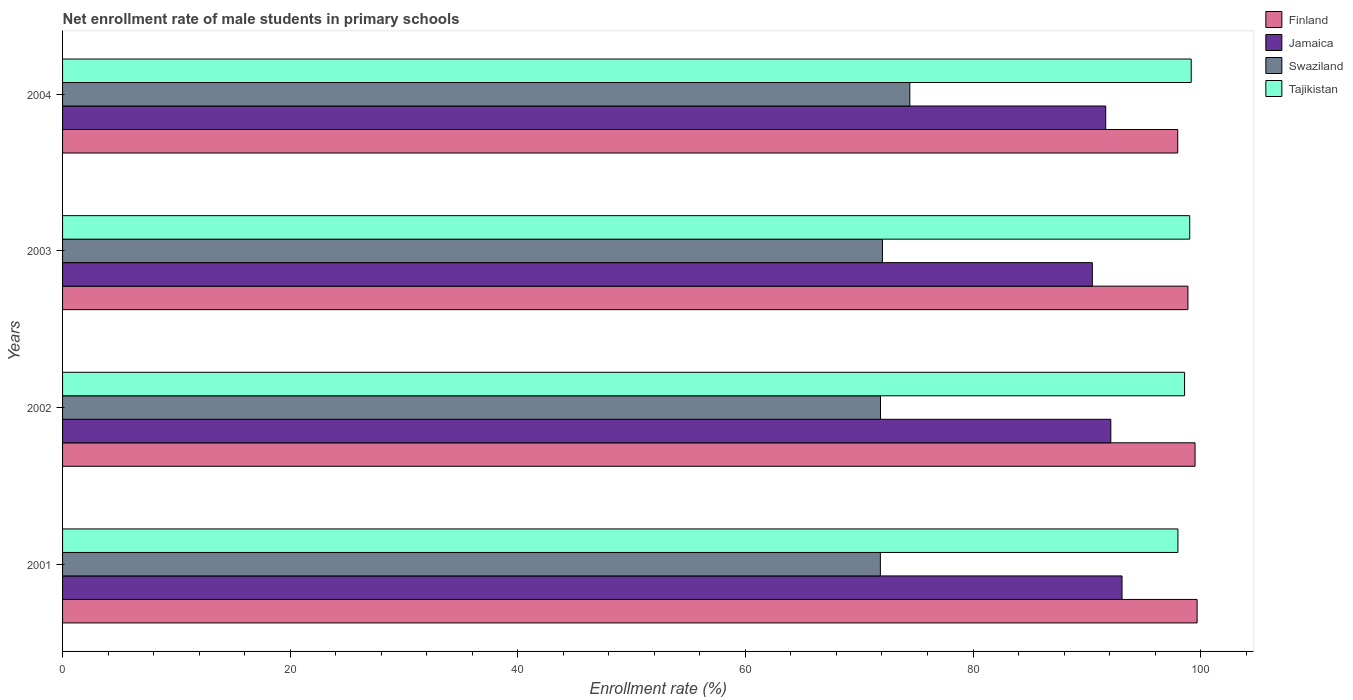How many groups of bars are there?
Keep it short and to the point. 4. How many bars are there on the 4th tick from the top?
Keep it short and to the point. 4. What is the label of the 3rd group of bars from the top?
Your response must be concise. 2002. What is the net enrollment rate of male students in primary schools in Finland in 2002?
Your answer should be very brief. 99.51. Across all years, what is the maximum net enrollment rate of male students in primary schools in Tajikistan?
Your response must be concise. 99.17. Across all years, what is the minimum net enrollment rate of male students in primary schools in Finland?
Provide a short and direct response. 97.99. In which year was the net enrollment rate of male students in primary schools in Finland minimum?
Provide a short and direct response. 2004. What is the total net enrollment rate of male students in primary schools in Jamaica in the graph?
Provide a succinct answer. 367.34. What is the difference between the net enrollment rate of male students in primary schools in Finland in 2002 and that in 2004?
Offer a very short reply. 1.52. What is the difference between the net enrollment rate of male students in primary schools in Swaziland in 2004 and the net enrollment rate of male students in primary schools in Jamaica in 2003?
Make the answer very short. -16.04. What is the average net enrollment rate of male students in primary schools in Tajikistan per year?
Your answer should be very brief. 98.7. In the year 2001, what is the difference between the net enrollment rate of male students in primary schools in Finland and net enrollment rate of male students in primary schools in Swaziland?
Provide a short and direct response. 27.83. What is the ratio of the net enrollment rate of male students in primary schools in Finland in 2001 to that in 2004?
Your answer should be very brief. 1.02. Is the difference between the net enrollment rate of male students in primary schools in Finland in 2002 and 2003 greater than the difference between the net enrollment rate of male students in primary schools in Swaziland in 2002 and 2003?
Ensure brevity in your answer.  Yes. What is the difference between the highest and the second highest net enrollment rate of male students in primary schools in Swaziland?
Your answer should be compact. 2.41. What is the difference between the highest and the lowest net enrollment rate of male students in primary schools in Finland?
Offer a very short reply. 1.7. Is the sum of the net enrollment rate of male students in primary schools in Jamaica in 2001 and 2002 greater than the maximum net enrollment rate of male students in primary schools in Tajikistan across all years?
Your response must be concise. Yes. What does the 2nd bar from the top in 2002 represents?
Your answer should be compact. Swaziland. What does the 4th bar from the bottom in 2004 represents?
Your response must be concise. Tajikistan. How many bars are there?
Offer a terse response. 16. How many years are there in the graph?
Keep it short and to the point. 4. What is the difference between two consecutive major ticks on the X-axis?
Keep it short and to the point. 20. Are the values on the major ticks of X-axis written in scientific E-notation?
Offer a terse response. No. Does the graph contain any zero values?
Give a very brief answer. No. How many legend labels are there?
Keep it short and to the point. 4. What is the title of the graph?
Your response must be concise. Net enrollment rate of male students in primary schools. What is the label or title of the X-axis?
Your answer should be compact. Enrollment rate (%). What is the label or title of the Y-axis?
Make the answer very short. Years. What is the Enrollment rate (%) in Finland in 2001?
Give a very brief answer. 99.69. What is the Enrollment rate (%) in Jamaica in 2001?
Offer a terse response. 93.09. What is the Enrollment rate (%) of Swaziland in 2001?
Offer a terse response. 71.86. What is the Enrollment rate (%) of Tajikistan in 2001?
Your answer should be compact. 98.01. What is the Enrollment rate (%) in Finland in 2002?
Provide a short and direct response. 99.51. What is the Enrollment rate (%) of Jamaica in 2002?
Ensure brevity in your answer.  92.11. What is the Enrollment rate (%) of Swaziland in 2002?
Offer a terse response. 71.87. What is the Enrollment rate (%) in Tajikistan in 2002?
Your answer should be compact. 98.59. What is the Enrollment rate (%) of Finland in 2003?
Your answer should be very brief. 98.88. What is the Enrollment rate (%) of Jamaica in 2003?
Offer a very short reply. 90.48. What is the Enrollment rate (%) of Swaziland in 2003?
Provide a succinct answer. 72.04. What is the Enrollment rate (%) in Tajikistan in 2003?
Provide a succinct answer. 99.04. What is the Enrollment rate (%) of Finland in 2004?
Provide a short and direct response. 97.99. What is the Enrollment rate (%) of Jamaica in 2004?
Give a very brief answer. 91.66. What is the Enrollment rate (%) of Swaziland in 2004?
Your answer should be compact. 74.45. What is the Enrollment rate (%) of Tajikistan in 2004?
Provide a short and direct response. 99.17. Across all years, what is the maximum Enrollment rate (%) in Finland?
Your answer should be compact. 99.69. Across all years, what is the maximum Enrollment rate (%) in Jamaica?
Your response must be concise. 93.09. Across all years, what is the maximum Enrollment rate (%) of Swaziland?
Offer a terse response. 74.45. Across all years, what is the maximum Enrollment rate (%) of Tajikistan?
Provide a succinct answer. 99.17. Across all years, what is the minimum Enrollment rate (%) in Finland?
Give a very brief answer. 97.99. Across all years, what is the minimum Enrollment rate (%) of Jamaica?
Give a very brief answer. 90.48. Across all years, what is the minimum Enrollment rate (%) of Swaziland?
Provide a succinct answer. 71.86. Across all years, what is the minimum Enrollment rate (%) of Tajikistan?
Make the answer very short. 98.01. What is the total Enrollment rate (%) of Finland in the graph?
Provide a succinct answer. 396.07. What is the total Enrollment rate (%) in Jamaica in the graph?
Give a very brief answer. 367.34. What is the total Enrollment rate (%) of Swaziland in the graph?
Your answer should be very brief. 290.21. What is the total Enrollment rate (%) in Tajikistan in the graph?
Provide a short and direct response. 394.81. What is the difference between the Enrollment rate (%) in Finland in 2001 and that in 2002?
Provide a short and direct response. 0.18. What is the difference between the Enrollment rate (%) in Jamaica in 2001 and that in 2002?
Your answer should be compact. 0.99. What is the difference between the Enrollment rate (%) in Swaziland in 2001 and that in 2002?
Your response must be concise. -0.01. What is the difference between the Enrollment rate (%) in Tajikistan in 2001 and that in 2002?
Ensure brevity in your answer.  -0.58. What is the difference between the Enrollment rate (%) in Finland in 2001 and that in 2003?
Make the answer very short. 0.81. What is the difference between the Enrollment rate (%) of Jamaica in 2001 and that in 2003?
Offer a very short reply. 2.61. What is the difference between the Enrollment rate (%) in Swaziland in 2001 and that in 2003?
Offer a terse response. -0.18. What is the difference between the Enrollment rate (%) of Tajikistan in 2001 and that in 2003?
Make the answer very short. -1.04. What is the difference between the Enrollment rate (%) in Finland in 2001 and that in 2004?
Provide a short and direct response. 1.7. What is the difference between the Enrollment rate (%) of Jamaica in 2001 and that in 2004?
Offer a very short reply. 1.43. What is the difference between the Enrollment rate (%) in Swaziland in 2001 and that in 2004?
Your answer should be very brief. -2.59. What is the difference between the Enrollment rate (%) in Tajikistan in 2001 and that in 2004?
Offer a very short reply. -1.17. What is the difference between the Enrollment rate (%) in Finland in 2002 and that in 2003?
Provide a short and direct response. 0.63. What is the difference between the Enrollment rate (%) in Jamaica in 2002 and that in 2003?
Provide a short and direct response. 1.62. What is the difference between the Enrollment rate (%) in Swaziland in 2002 and that in 2003?
Provide a short and direct response. -0.17. What is the difference between the Enrollment rate (%) of Tajikistan in 2002 and that in 2003?
Provide a short and direct response. -0.46. What is the difference between the Enrollment rate (%) of Finland in 2002 and that in 2004?
Provide a short and direct response. 1.52. What is the difference between the Enrollment rate (%) in Jamaica in 2002 and that in 2004?
Provide a succinct answer. 0.45. What is the difference between the Enrollment rate (%) of Swaziland in 2002 and that in 2004?
Keep it short and to the point. -2.57. What is the difference between the Enrollment rate (%) in Tajikistan in 2002 and that in 2004?
Make the answer very short. -0.58. What is the difference between the Enrollment rate (%) in Finland in 2003 and that in 2004?
Provide a short and direct response. 0.9. What is the difference between the Enrollment rate (%) of Jamaica in 2003 and that in 2004?
Make the answer very short. -1.17. What is the difference between the Enrollment rate (%) of Swaziland in 2003 and that in 2004?
Offer a very short reply. -2.41. What is the difference between the Enrollment rate (%) in Tajikistan in 2003 and that in 2004?
Ensure brevity in your answer.  -0.13. What is the difference between the Enrollment rate (%) of Finland in 2001 and the Enrollment rate (%) of Jamaica in 2002?
Offer a very short reply. 7.58. What is the difference between the Enrollment rate (%) of Finland in 2001 and the Enrollment rate (%) of Swaziland in 2002?
Provide a short and direct response. 27.82. What is the difference between the Enrollment rate (%) of Finland in 2001 and the Enrollment rate (%) of Tajikistan in 2002?
Provide a short and direct response. 1.1. What is the difference between the Enrollment rate (%) of Jamaica in 2001 and the Enrollment rate (%) of Swaziland in 2002?
Your response must be concise. 21.22. What is the difference between the Enrollment rate (%) of Jamaica in 2001 and the Enrollment rate (%) of Tajikistan in 2002?
Make the answer very short. -5.49. What is the difference between the Enrollment rate (%) of Swaziland in 2001 and the Enrollment rate (%) of Tajikistan in 2002?
Give a very brief answer. -26.73. What is the difference between the Enrollment rate (%) in Finland in 2001 and the Enrollment rate (%) in Jamaica in 2003?
Provide a short and direct response. 9.21. What is the difference between the Enrollment rate (%) of Finland in 2001 and the Enrollment rate (%) of Swaziland in 2003?
Offer a terse response. 27.65. What is the difference between the Enrollment rate (%) of Finland in 2001 and the Enrollment rate (%) of Tajikistan in 2003?
Your answer should be compact. 0.65. What is the difference between the Enrollment rate (%) of Jamaica in 2001 and the Enrollment rate (%) of Swaziland in 2003?
Make the answer very short. 21.05. What is the difference between the Enrollment rate (%) in Jamaica in 2001 and the Enrollment rate (%) in Tajikistan in 2003?
Make the answer very short. -5.95. What is the difference between the Enrollment rate (%) of Swaziland in 2001 and the Enrollment rate (%) of Tajikistan in 2003?
Offer a very short reply. -27.19. What is the difference between the Enrollment rate (%) in Finland in 2001 and the Enrollment rate (%) in Jamaica in 2004?
Provide a succinct answer. 8.03. What is the difference between the Enrollment rate (%) in Finland in 2001 and the Enrollment rate (%) in Swaziland in 2004?
Keep it short and to the point. 25.24. What is the difference between the Enrollment rate (%) of Finland in 2001 and the Enrollment rate (%) of Tajikistan in 2004?
Your response must be concise. 0.52. What is the difference between the Enrollment rate (%) in Jamaica in 2001 and the Enrollment rate (%) in Swaziland in 2004?
Offer a very short reply. 18.65. What is the difference between the Enrollment rate (%) of Jamaica in 2001 and the Enrollment rate (%) of Tajikistan in 2004?
Offer a very short reply. -6.08. What is the difference between the Enrollment rate (%) in Swaziland in 2001 and the Enrollment rate (%) in Tajikistan in 2004?
Provide a short and direct response. -27.31. What is the difference between the Enrollment rate (%) in Finland in 2002 and the Enrollment rate (%) in Jamaica in 2003?
Your response must be concise. 9.03. What is the difference between the Enrollment rate (%) in Finland in 2002 and the Enrollment rate (%) in Swaziland in 2003?
Provide a succinct answer. 27.47. What is the difference between the Enrollment rate (%) in Finland in 2002 and the Enrollment rate (%) in Tajikistan in 2003?
Ensure brevity in your answer.  0.47. What is the difference between the Enrollment rate (%) in Jamaica in 2002 and the Enrollment rate (%) in Swaziland in 2003?
Your answer should be very brief. 20.07. What is the difference between the Enrollment rate (%) in Jamaica in 2002 and the Enrollment rate (%) in Tajikistan in 2003?
Your answer should be very brief. -6.94. What is the difference between the Enrollment rate (%) in Swaziland in 2002 and the Enrollment rate (%) in Tajikistan in 2003?
Your response must be concise. -27.17. What is the difference between the Enrollment rate (%) in Finland in 2002 and the Enrollment rate (%) in Jamaica in 2004?
Your answer should be very brief. 7.85. What is the difference between the Enrollment rate (%) in Finland in 2002 and the Enrollment rate (%) in Swaziland in 2004?
Give a very brief answer. 25.06. What is the difference between the Enrollment rate (%) of Finland in 2002 and the Enrollment rate (%) of Tajikistan in 2004?
Provide a short and direct response. 0.34. What is the difference between the Enrollment rate (%) in Jamaica in 2002 and the Enrollment rate (%) in Swaziland in 2004?
Provide a short and direct response. 17.66. What is the difference between the Enrollment rate (%) of Jamaica in 2002 and the Enrollment rate (%) of Tajikistan in 2004?
Your response must be concise. -7.06. What is the difference between the Enrollment rate (%) of Swaziland in 2002 and the Enrollment rate (%) of Tajikistan in 2004?
Ensure brevity in your answer.  -27.3. What is the difference between the Enrollment rate (%) of Finland in 2003 and the Enrollment rate (%) of Jamaica in 2004?
Make the answer very short. 7.23. What is the difference between the Enrollment rate (%) in Finland in 2003 and the Enrollment rate (%) in Swaziland in 2004?
Provide a succinct answer. 24.44. What is the difference between the Enrollment rate (%) of Finland in 2003 and the Enrollment rate (%) of Tajikistan in 2004?
Provide a succinct answer. -0.29. What is the difference between the Enrollment rate (%) in Jamaica in 2003 and the Enrollment rate (%) in Swaziland in 2004?
Offer a very short reply. 16.04. What is the difference between the Enrollment rate (%) in Jamaica in 2003 and the Enrollment rate (%) in Tajikistan in 2004?
Your answer should be very brief. -8.69. What is the difference between the Enrollment rate (%) of Swaziland in 2003 and the Enrollment rate (%) of Tajikistan in 2004?
Make the answer very short. -27.13. What is the average Enrollment rate (%) in Finland per year?
Keep it short and to the point. 99.02. What is the average Enrollment rate (%) in Jamaica per year?
Ensure brevity in your answer.  91.84. What is the average Enrollment rate (%) in Swaziland per year?
Offer a very short reply. 72.55. What is the average Enrollment rate (%) of Tajikistan per year?
Offer a terse response. 98.7. In the year 2001, what is the difference between the Enrollment rate (%) in Finland and Enrollment rate (%) in Jamaica?
Provide a succinct answer. 6.6. In the year 2001, what is the difference between the Enrollment rate (%) in Finland and Enrollment rate (%) in Swaziland?
Your answer should be very brief. 27.83. In the year 2001, what is the difference between the Enrollment rate (%) of Finland and Enrollment rate (%) of Tajikistan?
Provide a succinct answer. 1.69. In the year 2001, what is the difference between the Enrollment rate (%) in Jamaica and Enrollment rate (%) in Swaziland?
Make the answer very short. 21.24. In the year 2001, what is the difference between the Enrollment rate (%) of Jamaica and Enrollment rate (%) of Tajikistan?
Give a very brief answer. -4.91. In the year 2001, what is the difference between the Enrollment rate (%) in Swaziland and Enrollment rate (%) in Tajikistan?
Offer a very short reply. -26.15. In the year 2002, what is the difference between the Enrollment rate (%) of Finland and Enrollment rate (%) of Jamaica?
Make the answer very short. 7.4. In the year 2002, what is the difference between the Enrollment rate (%) in Finland and Enrollment rate (%) in Swaziland?
Your response must be concise. 27.64. In the year 2002, what is the difference between the Enrollment rate (%) in Finland and Enrollment rate (%) in Tajikistan?
Offer a terse response. 0.92. In the year 2002, what is the difference between the Enrollment rate (%) of Jamaica and Enrollment rate (%) of Swaziland?
Offer a very short reply. 20.24. In the year 2002, what is the difference between the Enrollment rate (%) in Jamaica and Enrollment rate (%) in Tajikistan?
Ensure brevity in your answer.  -6.48. In the year 2002, what is the difference between the Enrollment rate (%) of Swaziland and Enrollment rate (%) of Tajikistan?
Keep it short and to the point. -26.72. In the year 2003, what is the difference between the Enrollment rate (%) of Finland and Enrollment rate (%) of Jamaica?
Your answer should be very brief. 8.4. In the year 2003, what is the difference between the Enrollment rate (%) of Finland and Enrollment rate (%) of Swaziland?
Provide a short and direct response. 26.84. In the year 2003, what is the difference between the Enrollment rate (%) in Finland and Enrollment rate (%) in Tajikistan?
Provide a short and direct response. -0.16. In the year 2003, what is the difference between the Enrollment rate (%) of Jamaica and Enrollment rate (%) of Swaziland?
Your answer should be compact. 18.44. In the year 2003, what is the difference between the Enrollment rate (%) in Jamaica and Enrollment rate (%) in Tajikistan?
Your response must be concise. -8.56. In the year 2003, what is the difference between the Enrollment rate (%) in Swaziland and Enrollment rate (%) in Tajikistan?
Your answer should be very brief. -27. In the year 2004, what is the difference between the Enrollment rate (%) of Finland and Enrollment rate (%) of Jamaica?
Ensure brevity in your answer.  6.33. In the year 2004, what is the difference between the Enrollment rate (%) in Finland and Enrollment rate (%) in Swaziland?
Ensure brevity in your answer.  23.54. In the year 2004, what is the difference between the Enrollment rate (%) of Finland and Enrollment rate (%) of Tajikistan?
Provide a succinct answer. -1.18. In the year 2004, what is the difference between the Enrollment rate (%) of Jamaica and Enrollment rate (%) of Swaziland?
Offer a very short reply. 17.21. In the year 2004, what is the difference between the Enrollment rate (%) of Jamaica and Enrollment rate (%) of Tajikistan?
Offer a very short reply. -7.51. In the year 2004, what is the difference between the Enrollment rate (%) in Swaziland and Enrollment rate (%) in Tajikistan?
Give a very brief answer. -24.73. What is the ratio of the Enrollment rate (%) in Finland in 2001 to that in 2002?
Offer a very short reply. 1. What is the ratio of the Enrollment rate (%) of Jamaica in 2001 to that in 2002?
Give a very brief answer. 1.01. What is the ratio of the Enrollment rate (%) of Tajikistan in 2001 to that in 2002?
Keep it short and to the point. 0.99. What is the ratio of the Enrollment rate (%) of Jamaica in 2001 to that in 2003?
Offer a very short reply. 1.03. What is the ratio of the Enrollment rate (%) of Swaziland in 2001 to that in 2003?
Provide a short and direct response. 1. What is the ratio of the Enrollment rate (%) of Finland in 2001 to that in 2004?
Your response must be concise. 1.02. What is the ratio of the Enrollment rate (%) of Jamaica in 2001 to that in 2004?
Give a very brief answer. 1.02. What is the ratio of the Enrollment rate (%) in Swaziland in 2001 to that in 2004?
Provide a succinct answer. 0.97. What is the ratio of the Enrollment rate (%) of Finland in 2002 to that in 2003?
Your answer should be compact. 1.01. What is the ratio of the Enrollment rate (%) in Jamaica in 2002 to that in 2003?
Offer a terse response. 1.02. What is the ratio of the Enrollment rate (%) of Swaziland in 2002 to that in 2003?
Give a very brief answer. 1. What is the ratio of the Enrollment rate (%) in Finland in 2002 to that in 2004?
Offer a terse response. 1.02. What is the ratio of the Enrollment rate (%) in Jamaica in 2002 to that in 2004?
Your answer should be very brief. 1. What is the ratio of the Enrollment rate (%) in Swaziland in 2002 to that in 2004?
Give a very brief answer. 0.97. What is the ratio of the Enrollment rate (%) in Finland in 2003 to that in 2004?
Your answer should be compact. 1.01. What is the ratio of the Enrollment rate (%) of Jamaica in 2003 to that in 2004?
Provide a succinct answer. 0.99. What is the ratio of the Enrollment rate (%) in Tajikistan in 2003 to that in 2004?
Offer a terse response. 1. What is the difference between the highest and the second highest Enrollment rate (%) in Finland?
Provide a short and direct response. 0.18. What is the difference between the highest and the second highest Enrollment rate (%) of Jamaica?
Provide a succinct answer. 0.99. What is the difference between the highest and the second highest Enrollment rate (%) of Swaziland?
Provide a short and direct response. 2.41. What is the difference between the highest and the second highest Enrollment rate (%) of Tajikistan?
Ensure brevity in your answer.  0.13. What is the difference between the highest and the lowest Enrollment rate (%) of Finland?
Offer a very short reply. 1.7. What is the difference between the highest and the lowest Enrollment rate (%) in Jamaica?
Your answer should be very brief. 2.61. What is the difference between the highest and the lowest Enrollment rate (%) of Swaziland?
Provide a succinct answer. 2.59. What is the difference between the highest and the lowest Enrollment rate (%) of Tajikistan?
Your response must be concise. 1.17. 